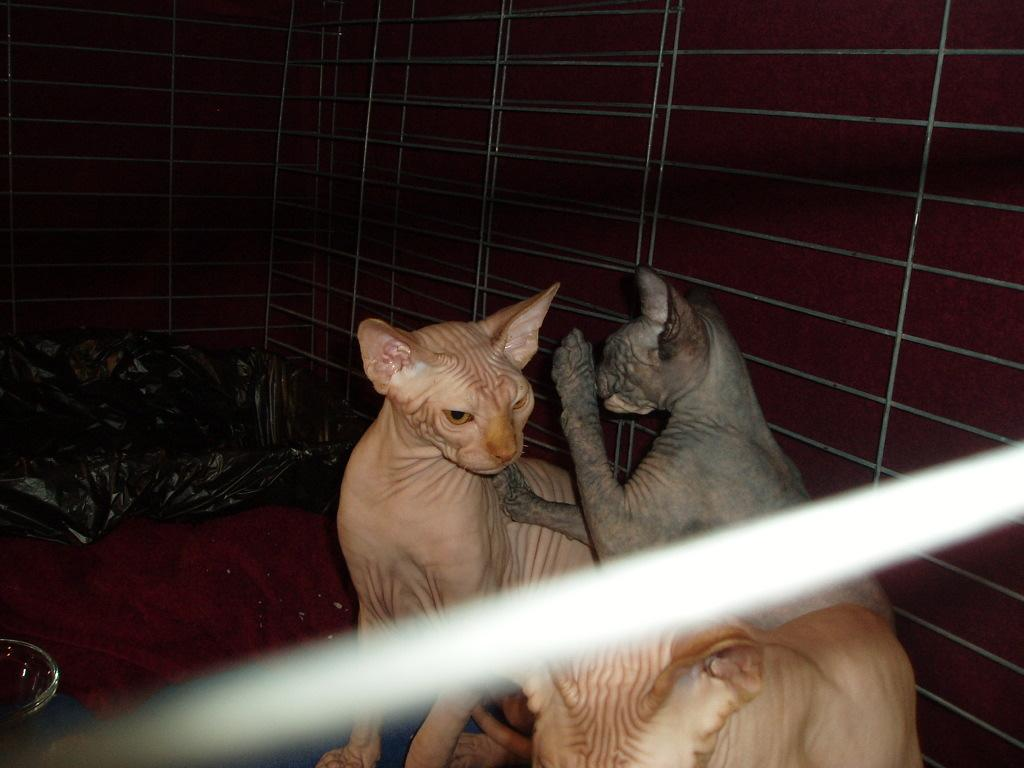How many cats are present in the image? There are two cats in the image. What can be seen in the background of the image? There is a wall in the background of the image. What is located on the left side of the image? There is a cover on the left side of the image. What type of patch is visible on the cats in the image? There are no patches visible on the cats in the image. How many bubbles are floating around the cats in the image? There are no bubbles present in the image. 